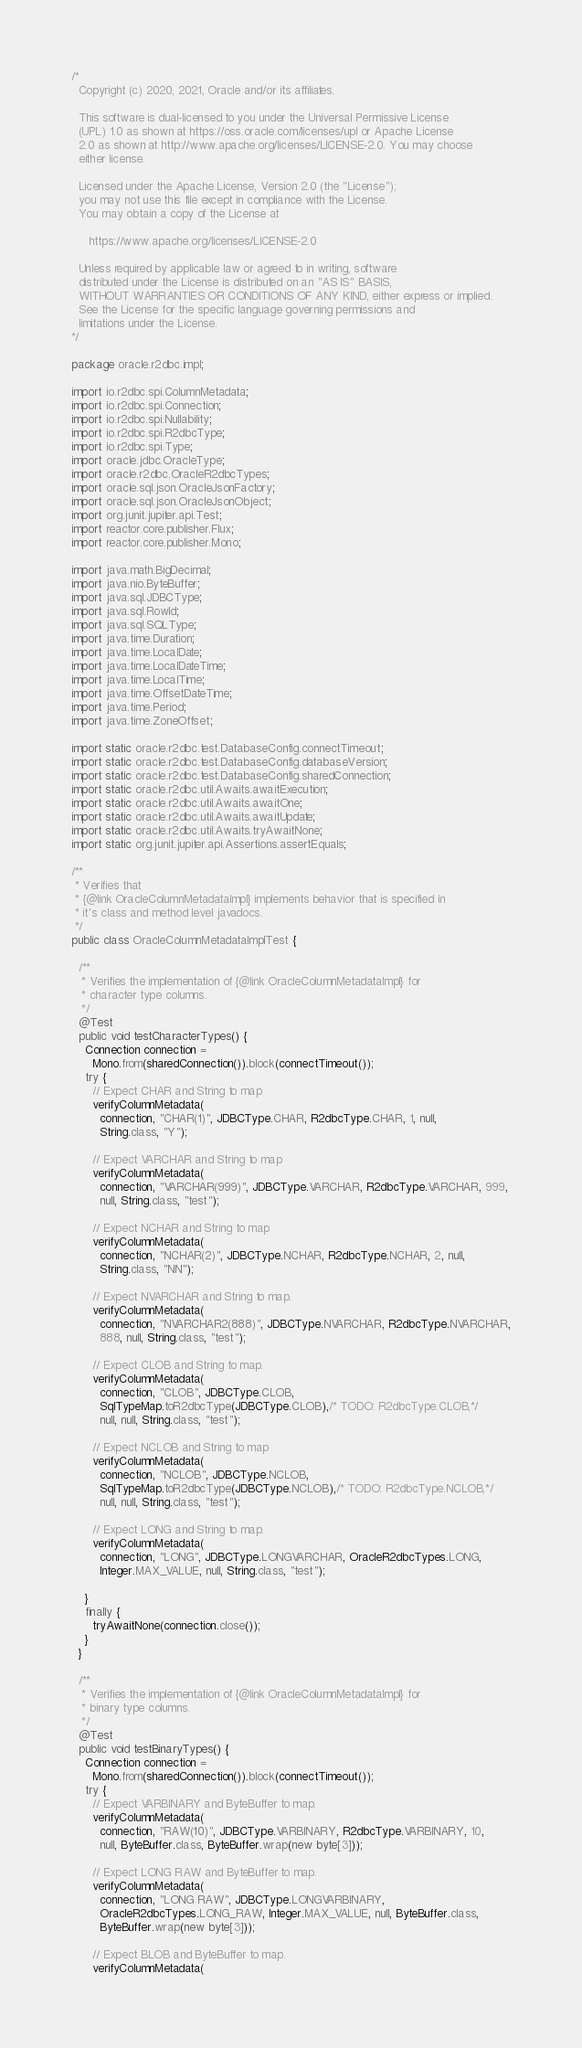<code> <loc_0><loc_0><loc_500><loc_500><_Java_>/*
  Copyright (c) 2020, 2021, Oracle and/or its affiliates.

  This software is dual-licensed to you under the Universal Permissive License 
  (UPL) 1.0 as shown at https://oss.oracle.com/licenses/upl or Apache License
  2.0 as shown at http://www.apache.org/licenses/LICENSE-2.0. You may choose
  either license.

  Licensed under the Apache License, Version 2.0 (the "License");
  you may not use this file except in compliance with the License.
  You may obtain a copy of the License at

     https://www.apache.org/licenses/LICENSE-2.0

  Unless required by applicable law or agreed to in writing, software
  distributed under the License is distributed on an "AS IS" BASIS,
  WITHOUT WARRANTIES OR CONDITIONS OF ANY KIND, either express or implied.
  See the License for the specific language governing permissions and
  limitations under the License.
*/

package oracle.r2dbc.impl;

import io.r2dbc.spi.ColumnMetadata;
import io.r2dbc.spi.Connection;
import io.r2dbc.spi.Nullability;
import io.r2dbc.spi.R2dbcType;
import io.r2dbc.spi.Type;
import oracle.jdbc.OracleType;
import oracle.r2dbc.OracleR2dbcTypes;
import oracle.sql.json.OracleJsonFactory;
import oracle.sql.json.OracleJsonObject;
import org.junit.jupiter.api.Test;
import reactor.core.publisher.Flux;
import reactor.core.publisher.Mono;

import java.math.BigDecimal;
import java.nio.ByteBuffer;
import java.sql.JDBCType;
import java.sql.RowId;
import java.sql.SQLType;
import java.time.Duration;
import java.time.LocalDate;
import java.time.LocalDateTime;
import java.time.LocalTime;
import java.time.OffsetDateTime;
import java.time.Period;
import java.time.ZoneOffset;

import static oracle.r2dbc.test.DatabaseConfig.connectTimeout;
import static oracle.r2dbc.test.DatabaseConfig.databaseVersion;
import static oracle.r2dbc.test.DatabaseConfig.sharedConnection;
import static oracle.r2dbc.util.Awaits.awaitExecution;
import static oracle.r2dbc.util.Awaits.awaitOne;
import static oracle.r2dbc.util.Awaits.awaitUpdate;
import static oracle.r2dbc.util.Awaits.tryAwaitNone;
import static org.junit.jupiter.api.Assertions.assertEquals;

/**
 * Verifies that
 * {@link OracleColumnMetadataImpl} implements behavior that is specified in
 * it's class and method level javadocs.
 */
public class OracleColumnMetadataImplTest {
  
  /**
   * Verifies the implementation of {@link OracleColumnMetadataImpl} for
   * character type columns.
   */
  @Test
  public void testCharacterTypes() {
    Connection connection =
      Mono.from(sharedConnection()).block(connectTimeout());
    try {
      // Expect CHAR and String to map
      verifyColumnMetadata(
        connection, "CHAR(1)", JDBCType.CHAR, R2dbcType.CHAR, 1, null,
        String.class, "Y");

      // Expect VARCHAR and String to map
      verifyColumnMetadata(
        connection, "VARCHAR(999)", JDBCType.VARCHAR, R2dbcType.VARCHAR, 999,
        null, String.class, "test");

      // Expect NCHAR and String to map
      verifyColumnMetadata(
        connection, "NCHAR(2)", JDBCType.NCHAR, R2dbcType.NCHAR, 2, null,
        String.class, "NN");

      // Expect NVARCHAR and String to map.
      verifyColumnMetadata(
        connection, "NVARCHAR2(888)", JDBCType.NVARCHAR, R2dbcType.NVARCHAR,
        888, null, String.class, "test");

      // Expect CLOB and String to map.
      verifyColumnMetadata(
        connection, "CLOB", JDBCType.CLOB,
        SqlTypeMap.toR2dbcType(JDBCType.CLOB),/* TODO: R2dbcType.CLOB,*/
        null, null, String.class, "test");

      // Expect NCLOB and String to map
      verifyColumnMetadata(
        connection, "NCLOB", JDBCType.NCLOB,
        SqlTypeMap.toR2dbcType(JDBCType.NCLOB),/* TODO: R2dbcType.NCLOB,*/
        null, null, String.class, "test");

      // Expect LONG and String to map.
      verifyColumnMetadata(
        connection, "LONG", JDBCType.LONGVARCHAR, OracleR2dbcTypes.LONG,
        Integer.MAX_VALUE, null, String.class, "test");

    }
    finally {
      tryAwaitNone(connection.close());
    }
  }

  /**
   * Verifies the implementation of {@link OracleColumnMetadataImpl} for
   * binary type columns.
   */
  @Test
  public void testBinaryTypes() {
    Connection connection =
      Mono.from(sharedConnection()).block(connectTimeout());
    try {
      // Expect VARBINARY and ByteBuffer to map.
      verifyColumnMetadata(
        connection, "RAW(10)", JDBCType.VARBINARY, R2dbcType.VARBINARY, 10,
        null, ByteBuffer.class, ByteBuffer.wrap(new byte[3]));

      // Expect LONG RAW and ByteBuffer to map.
      verifyColumnMetadata(
        connection, "LONG RAW", JDBCType.LONGVARBINARY,
        OracleR2dbcTypes.LONG_RAW, Integer.MAX_VALUE, null, ByteBuffer.class,
        ByteBuffer.wrap(new byte[3]));

      // Expect BLOB and ByteBuffer to map.
      verifyColumnMetadata(</code> 